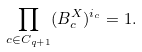<formula> <loc_0><loc_0><loc_500><loc_500>\prod _ { c \in C _ { q + 1 } } ( B _ { c } ^ { X } ) ^ { i _ { c } } = 1 .</formula> 